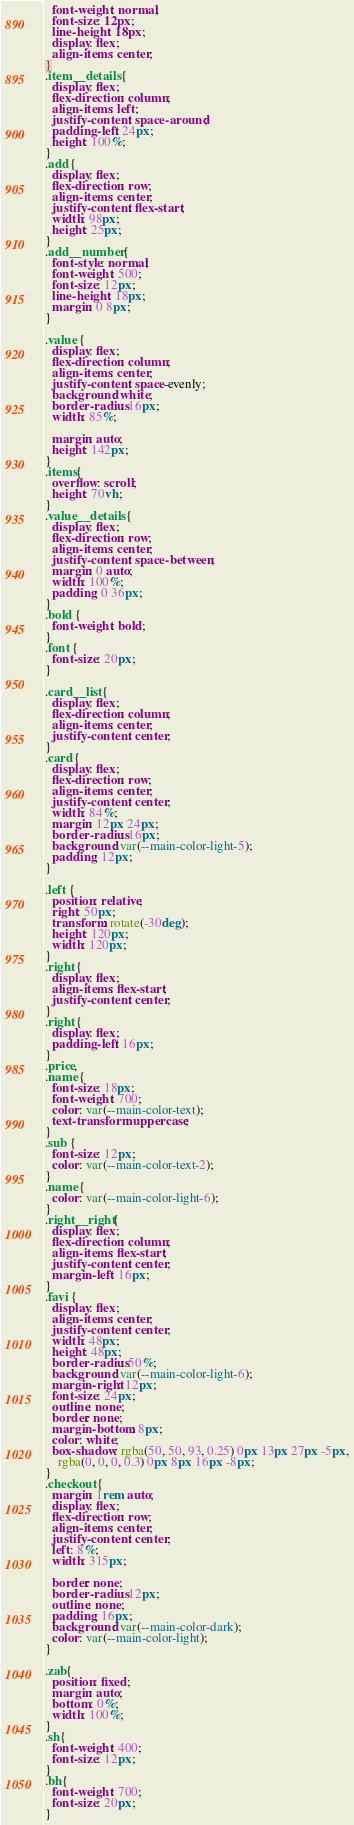Convert code to text. <code><loc_0><loc_0><loc_500><loc_500><_CSS_>  font-weight: normal;
  font-size: 12px;
  line-height: 18px;
  display: flex;
  align-items: center;
}
.item__details {
  display: flex;
  flex-direction: column;
  align-items: left;
  justify-content: space-around;
  padding-left: 24px;
  height: 100%;
}
.add {
  display: flex;
  flex-direction: row;
  align-items: center;
  justify-content: flex-start;
  width: 98px;
  height: 25px;
}
.add__number {
  font-style: normal;
  font-weight: 500;
  font-size: 12px;
  line-height: 18px;
  margin: 0 8px;
}

.value {
  display: flex;
  flex-direction: column;
  align-items: center;
  justify-content: space-evenly;
  background: white;
  border-radius: 16px;
  width: 85%;

  margin: auto;
  height: 142px;
}
.items{
  overflow: scroll;
  height: 70vh;
}
.value__details {
  display: flex;
  flex-direction: row;
  align-items: center;
  justify-content: space-between;
  margin: 0 auto;
  width: 100%;
  padding: 0 36px;
}
.bold {
  font-weight: bold;
}
.font {
  font-size: 20px;
}

.card__list {
  display: flex;
  flex-direction: column;
  align-items: center;
  justify-content: center;
}
.card {
  display: flex;
  flex-direction: row;
  align-items: center;
  justify-content: center;
  width: 84%;
  margin: 12px 24px;
  border-radius: 16px;
  background: var(--main-color-light-5);
  padding: 12px;
}

.left {
  position: relative;
  right: 50px;
  transform: rotate(-30deg);
  height: 120px;
  width: 120px;
}
.right {
  display: flex;
  align-items: flex-start;
  justify-content: center;
}
.right {
  display: flex;
  padding-left: 16px;
}
.price,
.name {
  font-size: 18px;
  font-weight: 700;
  color: var(--main-color-text);
  text-transform: uppercase;
}
.sub {
  font-size: 12px;
  color: var(--main-color-text-2);
}
.name {
  color: var(--main-color-light-6);
}
.right__right {
  display: flex;
  flex-direction: column;
  align-items: flex-start;
  justify-content: center;
  margin-left: 16px;
}
.favi {
  display: flex;
  align-items: center;
  justify-content: center;
  width: 48px;
  height: 48px;
  border-radius: 50%;
  background: var(--main-color-light-6);
  margin-right: 12px;
  font-size: 24px;
  outline: none;
  border: none;
  margin-bottom: 8px;
  color: white;
  box-shadow: rgba(50, 50, 93, 0.25) 0px 13px 27px -5px,
    rgba(0, 0, 0, 0.3) 0px 8px 16px -8px;
}
.checkout {
  margin: 1rem auto;
  display: flex;
  flex-direction: row;
  align-items: center;
  justify-content: center;
  left: 8%;
  width: 315px;

  border: none;
  border-radius: 12px;
  outline: none;
  padding: 16px;
  background: var(--main-color-dark);
  color: var(--main-color-light);
}

.zab{
  position: fixed;
  margin: auto;
  bottom: 0%;
  width: 100%;
}
.sh{
  font-weight: 400;
  font-size: 12px;
}
.bh{
  font-weight: 700;
  font-size: 20px;
}</code> 